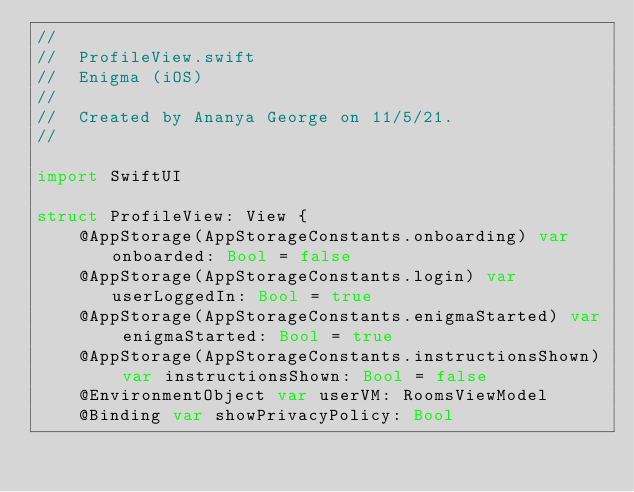Convert code to text. <code><loc_0><loc_0><loc_500><loc_500><_Swift_>//
//  ProfileView.swift
//  Enigma (iOS)
//
//  Created by Ananya George on 11/5/21.
//

import SwiftUI

struct ProfileView: View {
    @AppStorage(AppStorageConstants.onboarding) var onboarded: Bool = false
    @AppStorage(AppStorageConstants.login) var userLoggedIn: Bool = true
    @AppStorage(AppStorageConstants.enigmaStarted) var enigmaStarted: Bool = true
    @AppStorage(AppStorageConstants.instructionsShown) var instructionsShown: Bool = false
    @EnvironmentObject var userVM: RoomsViewModel
    @Binding var showPrivacyPolicy: Bool</code> 